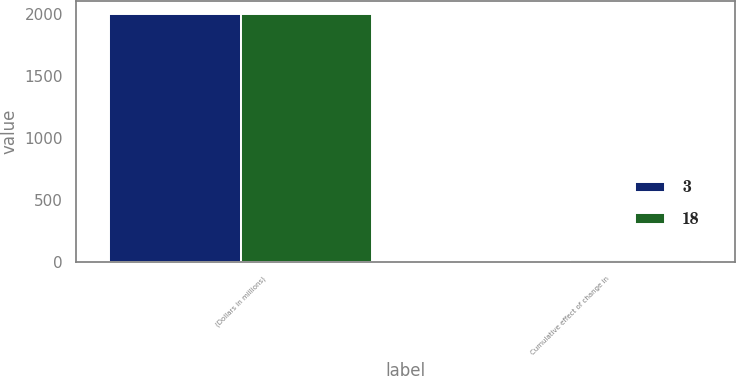<chart> <loc_0><loc_0><loc_500><loc_500><stacked_bar_chart><ecel><fcel>(Dollars in millions)<fcel>Cumulative effect of change in<nl><fcel>3<fcel>2003<fcel>3<nl><fcel>18<fcel>2002<fcel>18<nl></chart> 